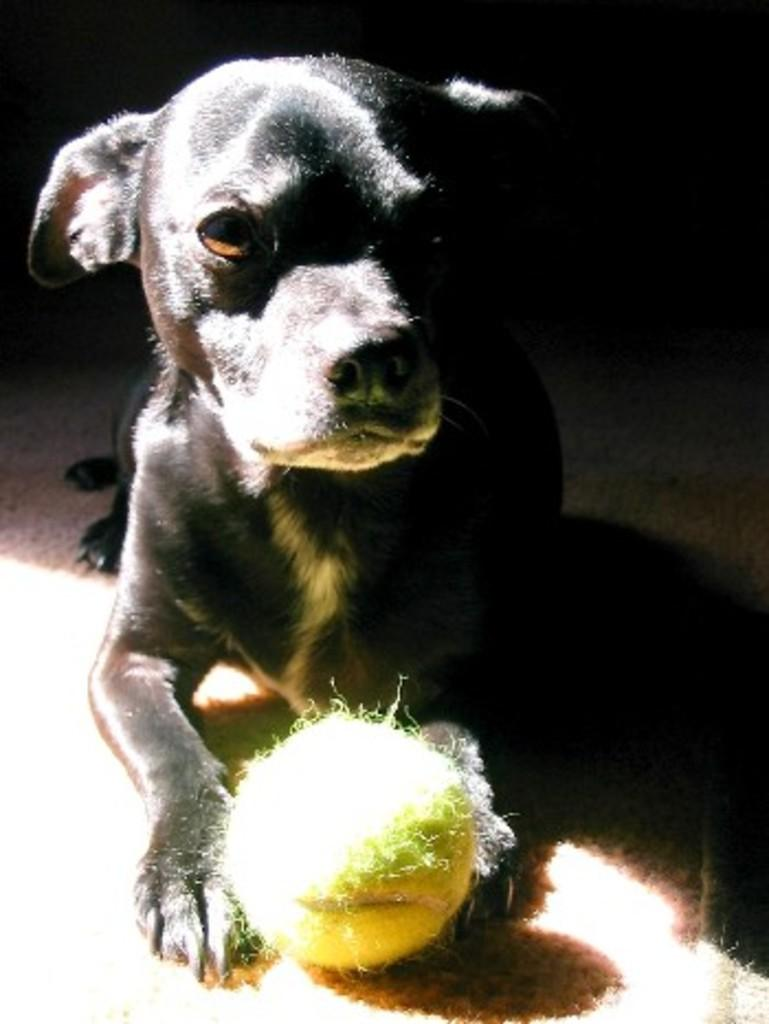What animal is present in the image? There is a dog in the image. What is the dog holding in the image? The dog is holding a ball. Can you describe the background of the image? The background of the image is dark. How many pigs are visible in the image? There are no pigs present in the image; it features a dog holding a ball. What type of butter is being used by the giants in the image? There are no giants or butter present in the image. 